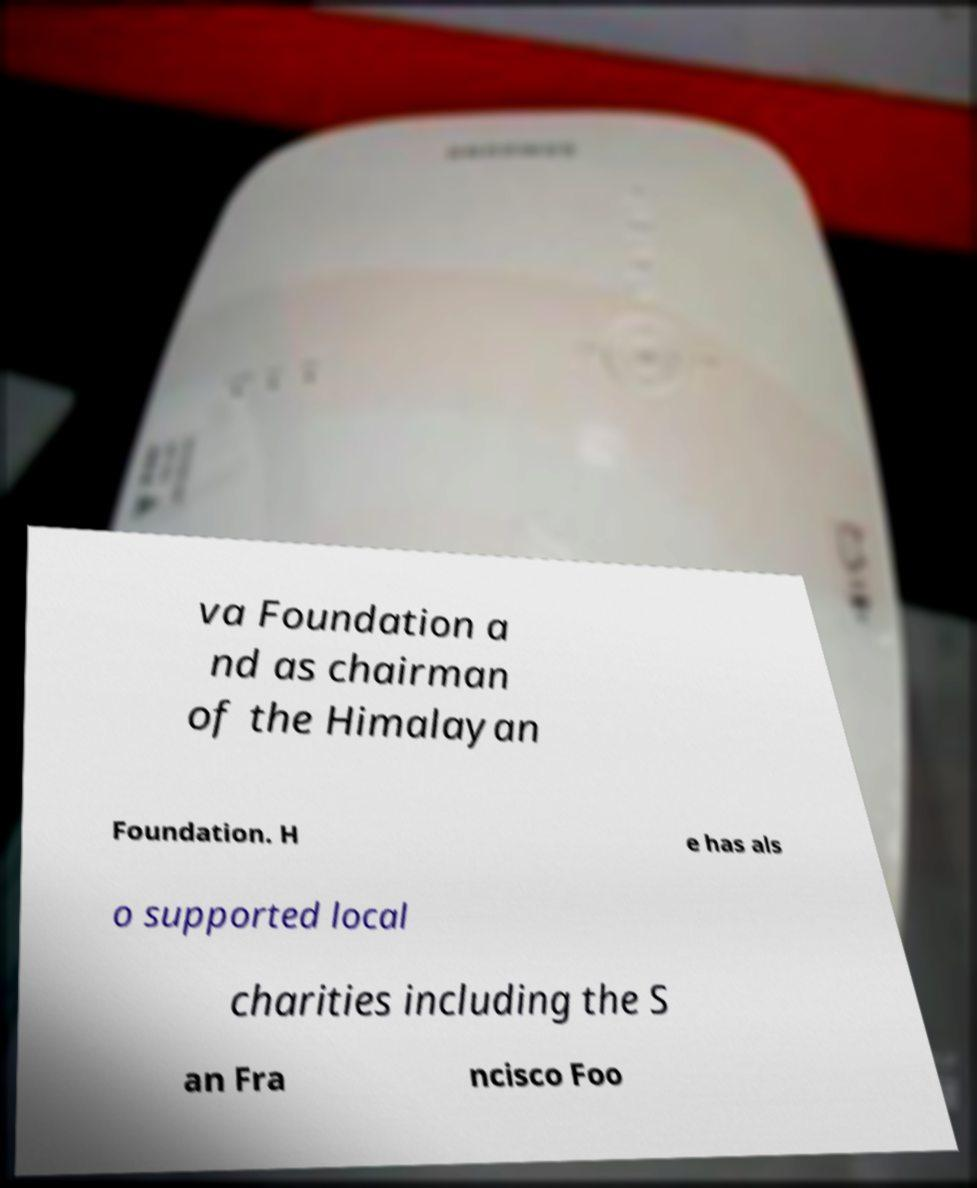For documentation purposes, I need the text within this image transcribed. Could you provide that? va Foundation a nd as chairman of the Himalayan Foundation. H e has als o supported local charities including the S an Fra ncisco Foo 